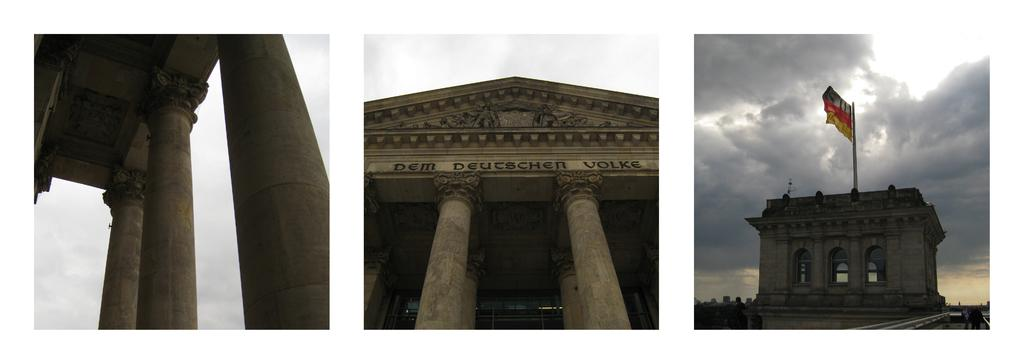How many different pictures are included in the collage? The image is a collage of three different pictures. What can be seen in the first two pictures? In the first two pictures, there are pillars. What is featured in the third picture? In the third picture, there is a building with a flag. What type of sheet is draped over the pillars in the image? There is no sheet present in the image; the collage only features pillars and a building with a flag. How does the harmony between the pillars and the building contribute to the overall aesthetic of the image? The concept of harmony is not applicable to the image, as it is a collage of separate pictures and does not depict a unified scene. 